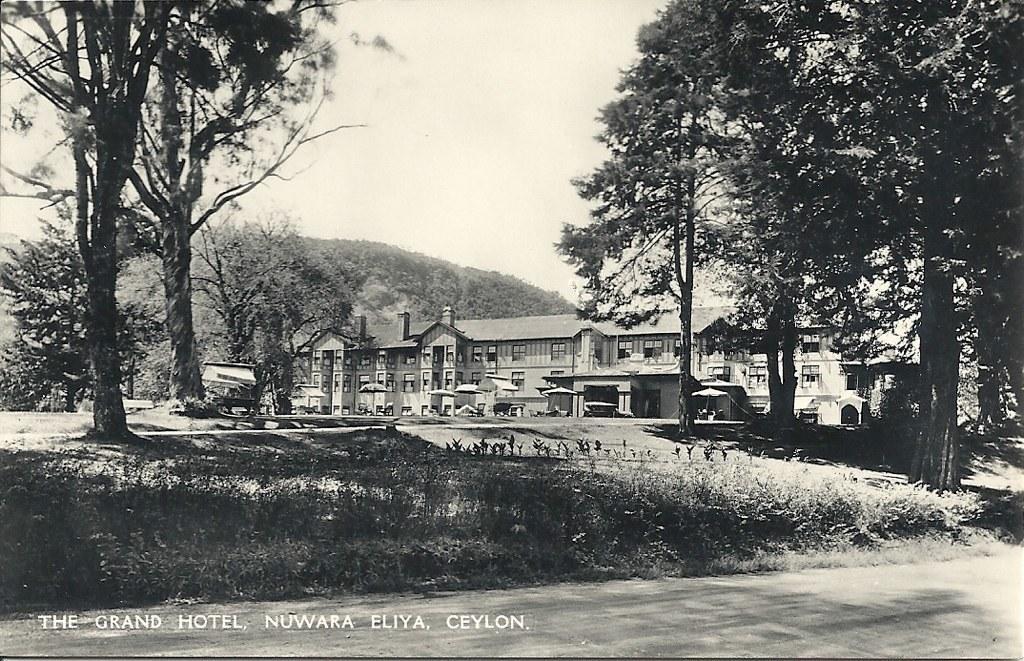How would you summarize this image in a sentence or two? In the picture I can see trees, plants, buildings, the sky and some other things. This image is black and white in color. I can also see a watermark on the image. 